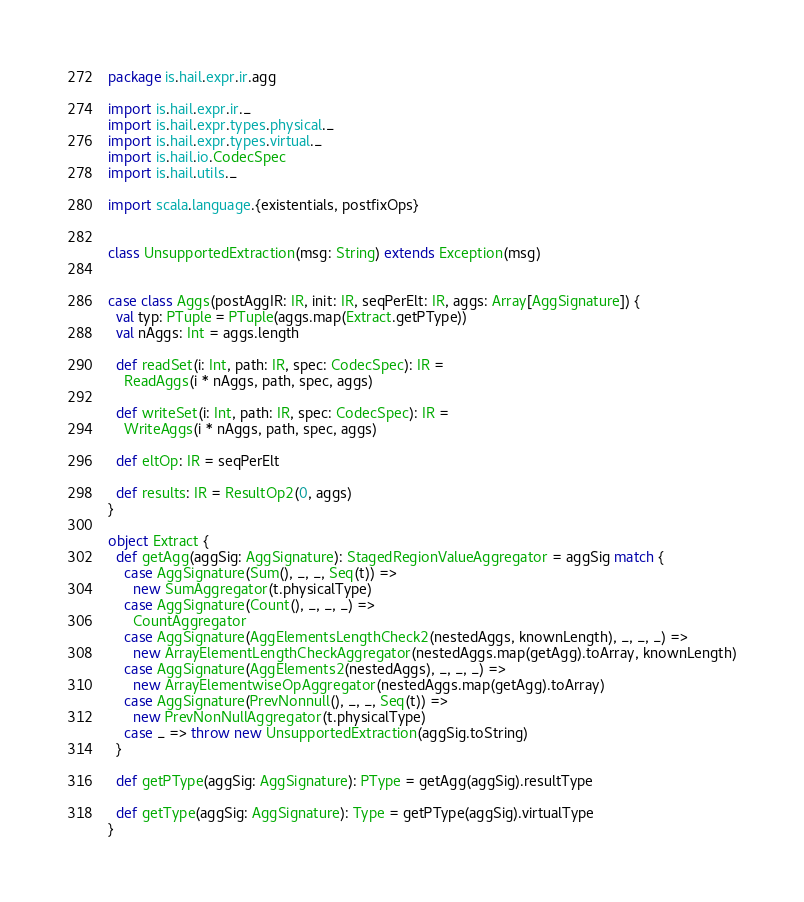Convert code to text. <code><loc_0><loc_0><loc_500><loc_500><_Scala_>package is.hail.expr.ir.agg

import is.hail.expr.ir._
import is.hail.expr.types.physical._
import is.hail.expr.types.virtual._
import is.hail.io.CodecSpec
import is.hail.utils._

import scala.language.{existentials, postfixOps}


class UnsupportedExtraction(msg: String) extends Exception(msg)


case class Aggs(postAggIR: IR, init: IR, seqPerElt: IR, aggs: Array[AggSignature]) {
  val typ: PTuple = PTuple(aggs.map(Extract.getPType))
  val nAggs: Int = aggs.length

  def readSet(i: Int, path: IR, spec: CodecSpec): IR =
    ReadAggs(i * nAggs, path, spec, aggs)

  def writeSet(i: Int, path: IR, spec: CodecSpec): IR =
    WriteAggs(i * nAggs, path, spec, aggs)

  def eltOp: IR = seqPerElt

  def results: IR = ResultOp2(0, aggs)
}

object Extract {
  def getAgg(aggSig: AggSignature): StagedRegionValueAggregator = aggSig match {
    case AggSignature(Sum(), _, _, Seq(t)) =>
      new SumAggregator(t.physicalType)
    case AggSignature(Count(), _, _, _) =>
      CountAggregator
    case AggSignature(AggElementsLengthCheck2(nestedAggs, knownLength), _, _, _) =>
      new ArrayElementLengthCheckAggregator(nestedAggs.map(getAgg).toArray, knownLength)
    case AggSignature(AggElements2(nestedAggs), _, _, _) =>
      new ArrayElementwiseOpAggregator(nestedAggs.map(getAgg).toArray)
    case AggSignature(PrevNonnull(), _, _, Seq(t)) =>
      new PrevNonNullAggregator(t.physicalType)
    case _ => throw new UnsupportedExtraction(aggSig.toString)
  }

  def getPType(aggSig: AggSignature): PType = getAgg(aggSig).resultType

  def getType(aggSig: AggSignature): Type = getPType(aggSig).virtualType
}
</code> 